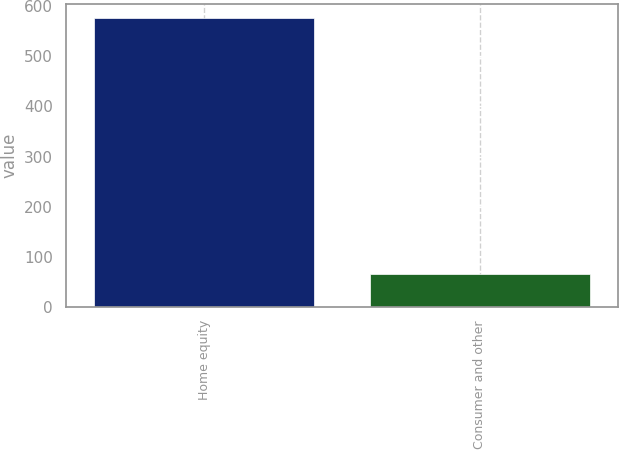Convert chart. <chart><loc_0><loc_0><loc_500><loc_500><bar_chart><fcel>Home equity<fcel>Consumer and other<nl><fcel>576.1<fcel>65.5<nl></chart> 